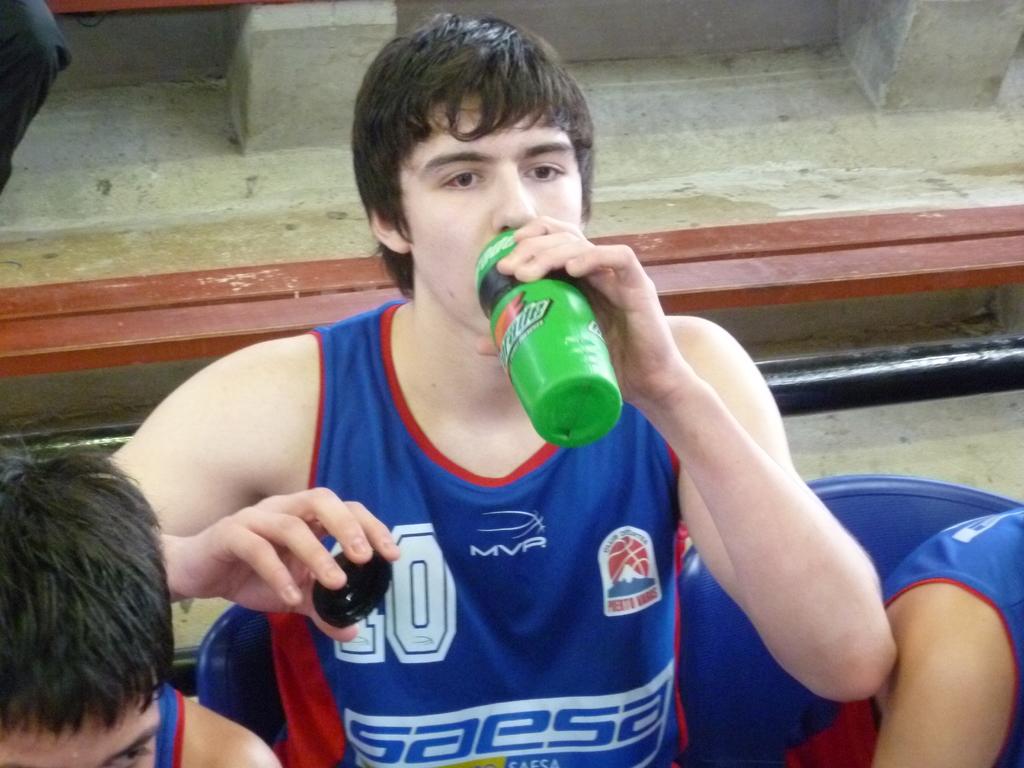What is printed on the water bottle?
Offer a terse response. Gatorade. Who is the sponsor on his shirt?
Provide a short and direct response. Saesa. 